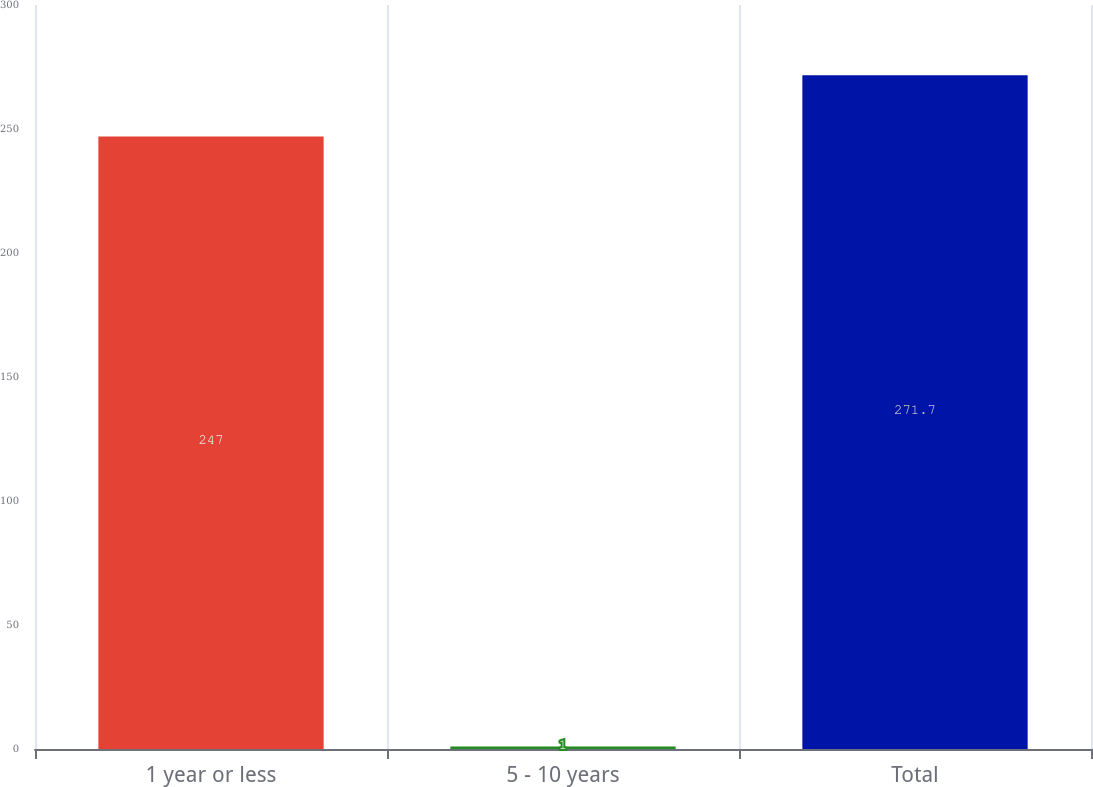Convert chart to OTSL. <chart><loc_0><loc_0><loc_500><loc_500><bar_chart><fcel>1 year or less<fcel>5 - 10 years<fcel>Total<nl><fcel>247<fcel>1<fcel>271.7<nl></chart> 